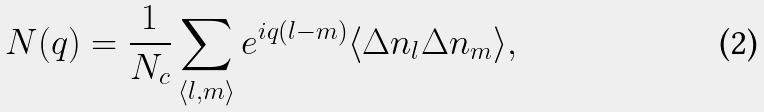<formula> <loc_0><loc_0><loc_500><loc_500>N ( q ) = \frac { 1 } { N _ { c } } \sum _ { \langle l , m \rangle } e ^ { i q ( l - m ) } \langle \Delta n _ { l } \Delta n _ { m } \rangle ,</formula> 